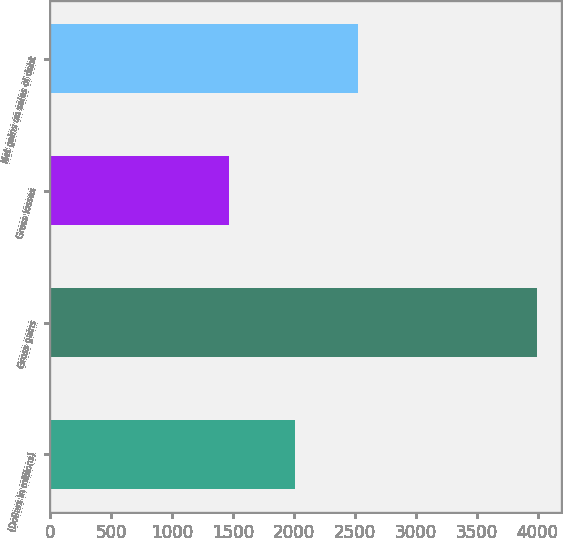Convert chart to OTSL. <chart><loc_0><loc_0><loc_500><loc_500><bar_chart><fcel>(Dollars in millions)<fcel>Gross gains<fcel>Gross losses<fcel>Net gains on sales of debt<nl><fcel>2010<fcel>3995<fcel>1469<fcel>2526<nl></chart> 